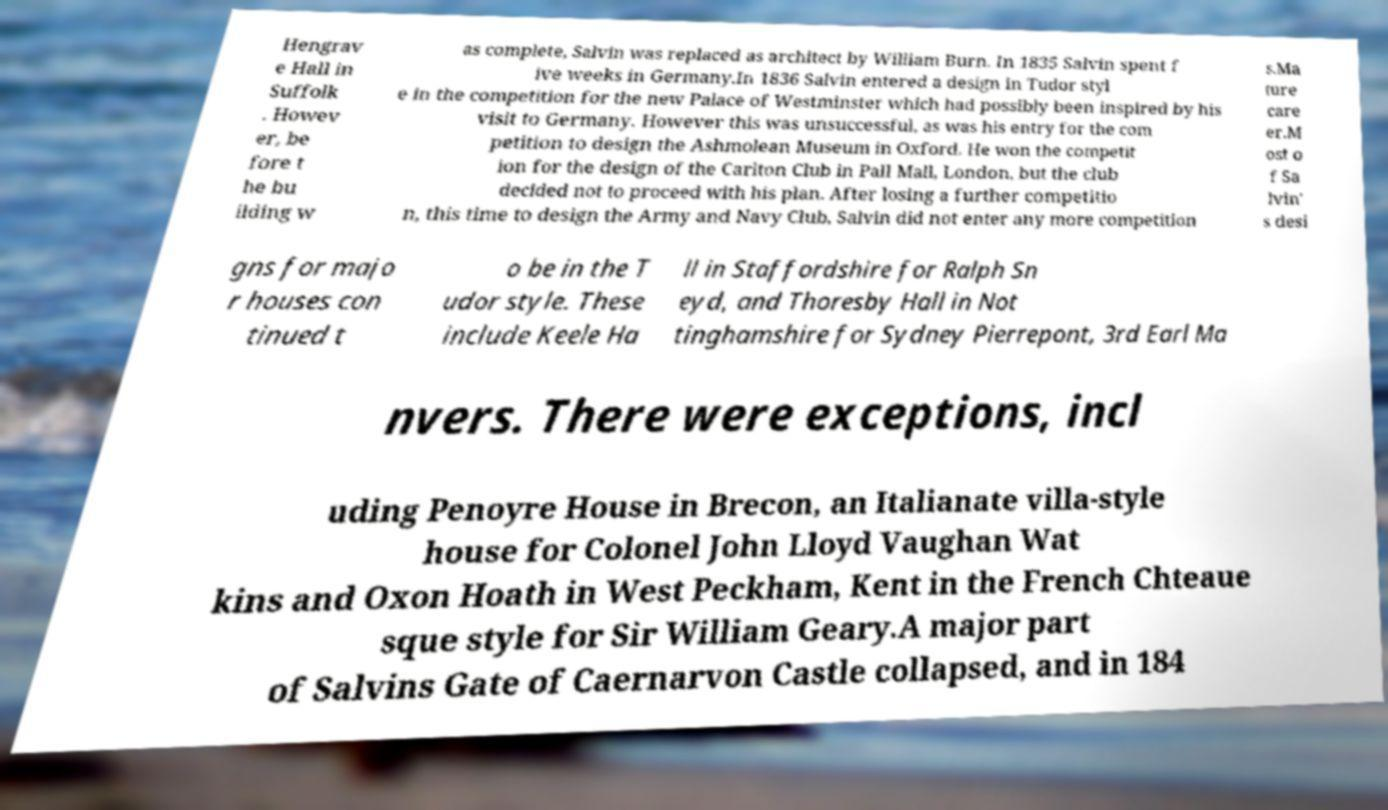Please identify and transcribe the text found in this image. Hengrav e Hall in Suffolk . Howev er, be fore t he bu ilding w as complete, Salvin was replaced as architect by William Burn. In 1835 Salvin spent f ive weeks in Germany.In 1836 Salvin entered a design in Tudor styl e in the competition for the new Palace of Westminster which had possibly been inspired by his visit to Germany. However this was unsuccessful, as was his entry for the com petition to design the Ashmolean Museum in Oxford. He won the competit ion for the design of the Carlton Club in Pall Mall, London, but the club decided not to proceed with his plan. After losing a further competitio n, this time to design the Army and Navy Club, Salvin did not enter any more competition s.Ma ture care er.M ost o f Sa lvin' s desi gns for majo r houses con tinued t o be in the T udor style. These include Keele Ha ll in Staffordshire for Ralph Sn eyd, and Thoresby Hall in Not tinghamshire for Sydney Pierrepont, 3rd Earl Ma nvers. There were exceptions, incl uding Penoyre House in Brecon, an Italianate villa-style house for Colonel John Lloyd Vaughan Wat kins and Oxon Hoath in West Peckham, Kent in the French Chteaue sque style for Sir William Geary.A major part of Salvins Gate of Caernarvon Castle collapsed, and in 184 